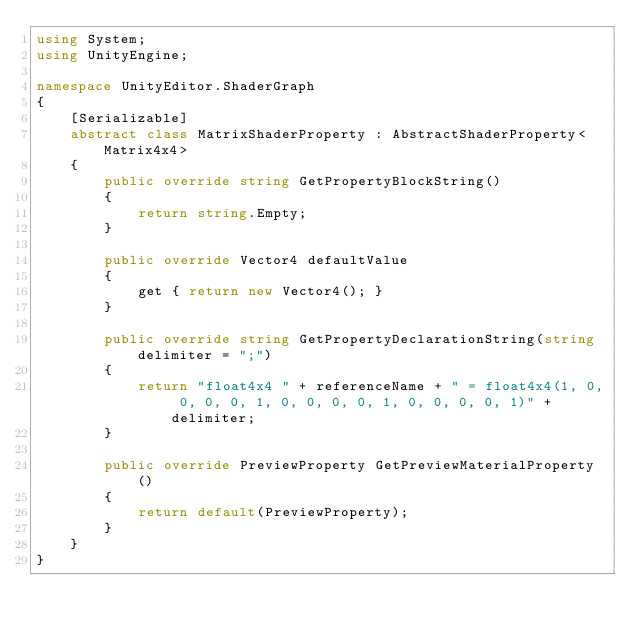<code> <loc_0><loc_0><loc_500><loc_500><_C#_>using System;
using UnityEngine;

namespace UnityEditor.ShaderGraph
{
    [Serializable]
    abstract class MatrixShaderProperty : AbstractShaderProperty<Matrix4x4>
    {
        public override string GetPropertyBlockString()
        {
            return string.Empty;
        }

        public override Vector4 defaultValue
        {
            get { return new Vector4(); }
        }

        public override string GetPropertyDeclarationString(string delimiter = ";")
        {
            return "float4x4 " + referenceName + " = float4x4(1, 0, 0, 0, 0, 1, 0, 0, 0, 0, 1, 0, 0, 0, 0, 1)" + delimiter;
        }

        public override PreviewProperty GetPreviewMaterialProperty()
        {
            return default(PreviewProperty);
        }
    }
}
</code> 